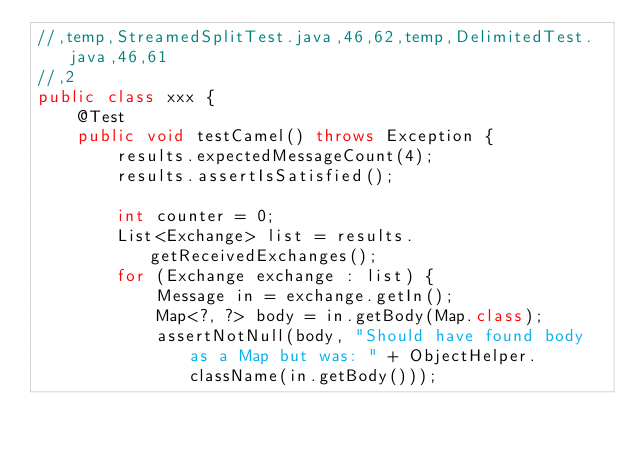<code> <loc_0><loc_0><loc_500><loc_500><_Java_>//,temp,StreamedSplitTest.java,46,62,temp,DelimitedTest.java,46,61
//,2
public class xxx {
    @Test
    public void testCamel() throws Exception {
        results.expectedMessageCount(4);
        results.assertIsSatisfied();

        int counter = 0;
        List<Exchange> list = results.getReceivedExchanges();
        for (Exchange exchange : list) {
            Message in = exchange.getIn();
            Map<?, ?> body = in.getBody(Map.class);
            assertNotNull(body, "Should have found body as a Map but was: " + ObjectHelper.className(in.getBody()));</code> 